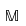Convert formula to latex. <formula><loc_0><loc_0><loc_500><loc_500>\mathbb { M }</formula> 